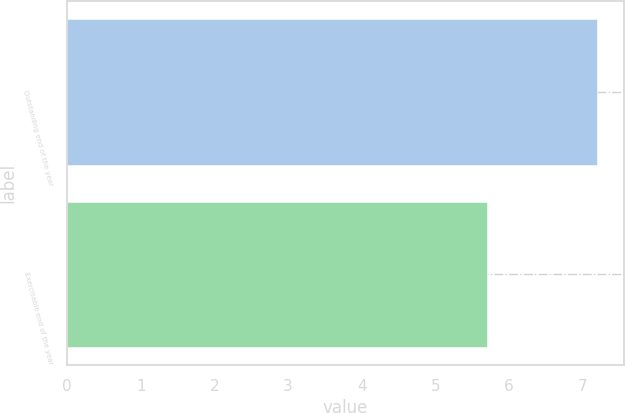Convert chart. <chart><loc_0><loc_0><loc_500><loc_500><bar_chart><fcel>Outstanding end of the year<fcel>Exercisable end of the year<nl><fcel>7.2<fcel>5.7<nl></chart> 